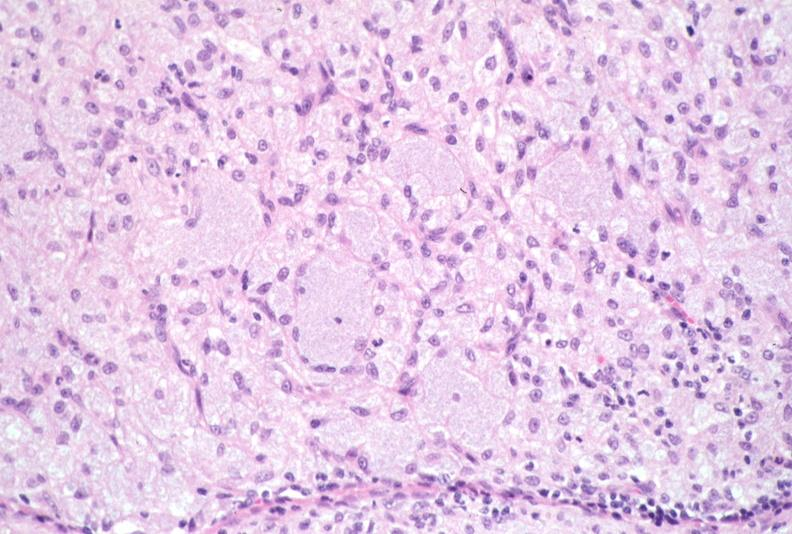does this image show lymph node, mycobacterium avium-intracellulae mai?
Answer the question using a single word or phrase. Yes 